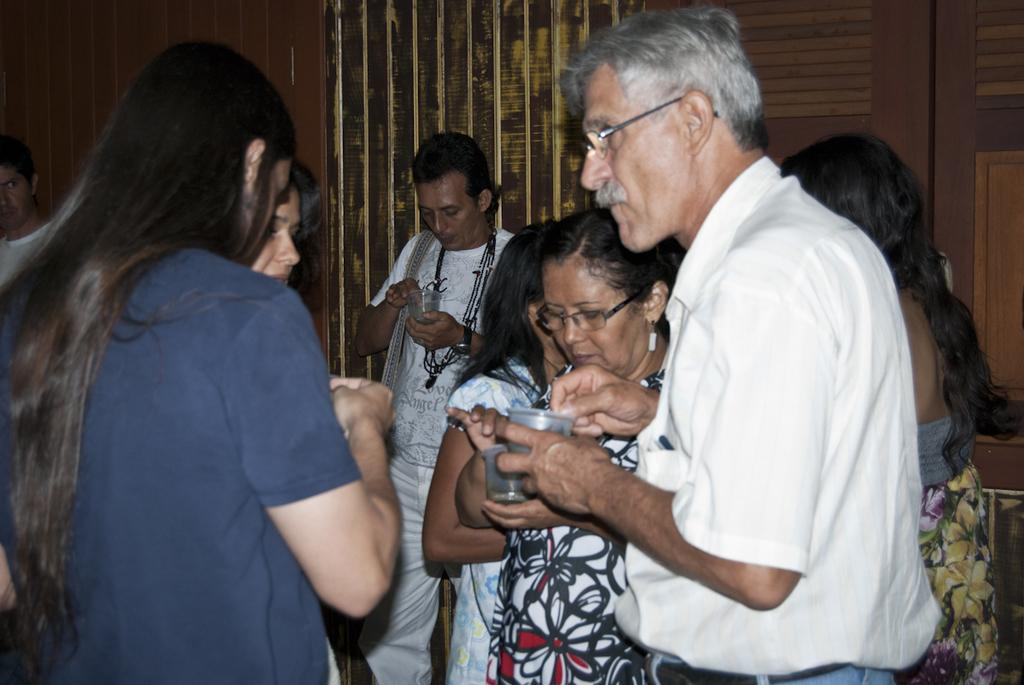Who or what can be seen in the image? There are people in the image. What are some of the people holding? Some of the people are holding cups. What type of furniture or storage is visible in the image? There is a closet in the image. What is the background of the image made up of? There is a wall in the image. How many twigs are being used as straws by the people in the image? There are no twigs present in the image, and they are not being used as straws. What type of geese can be seen flying in the background of the image? There are no geese present in the image, and they cannot be seen flying in the background. 